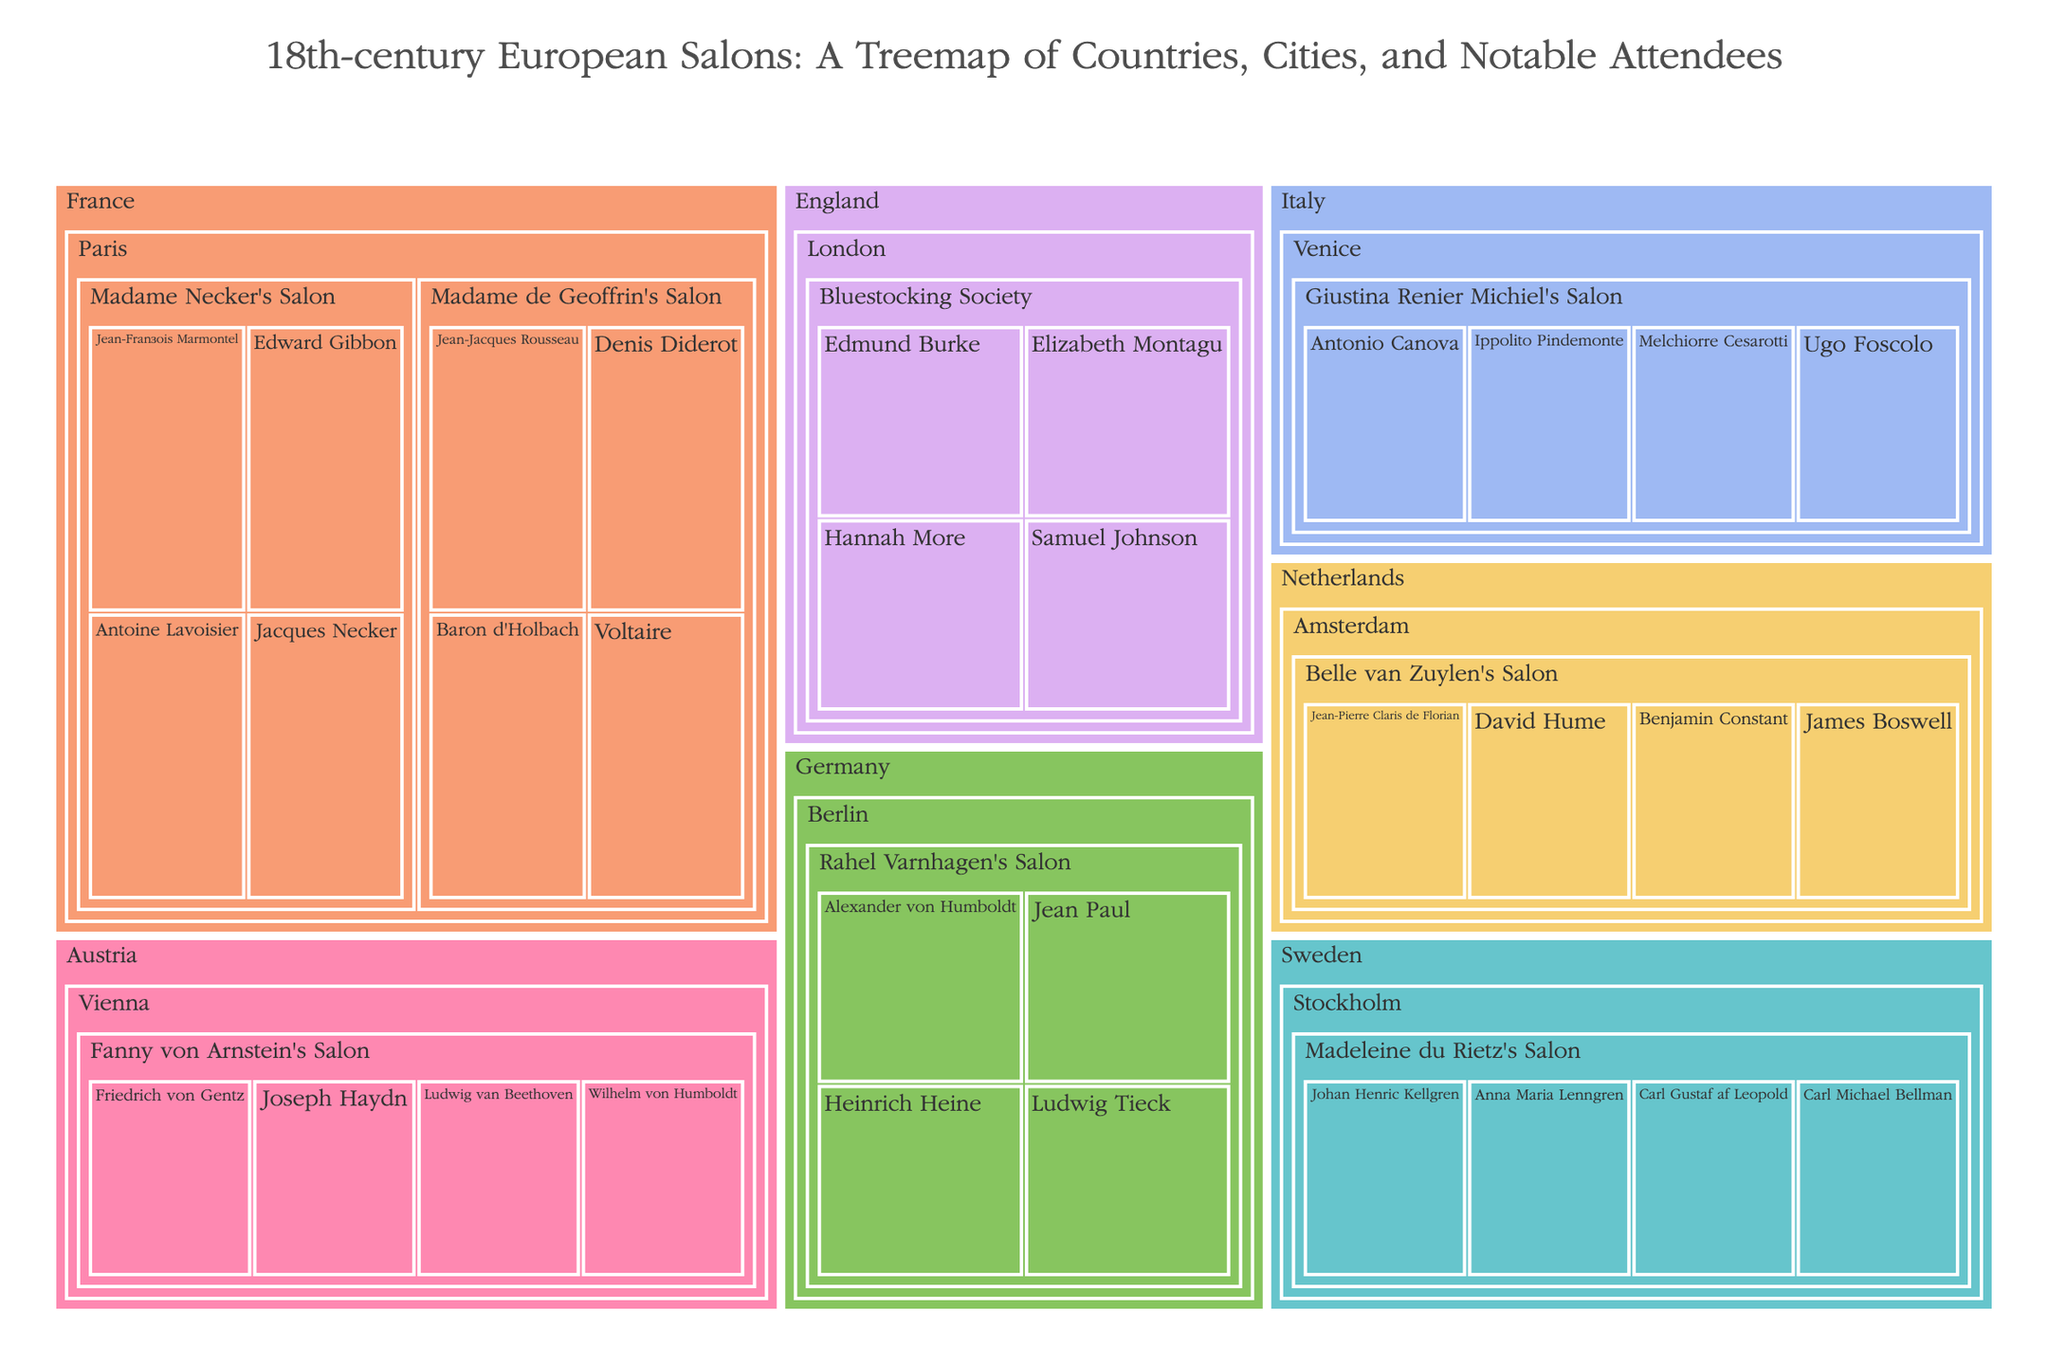What is the title of the treemap? The title of the treemap is located at the top of the figure. Reading it will provide the exact wording.
Answer: 18th-century European Salons: A Treemap of Countries, Cities, and Notable Attendees Which country has the most salons represented? By examining the size of the areas and labels, you can see which country has the most salons displayed.
Answer: France How many notable attendees are listed for Madame de Geoffrin's Salon in Paris, France? Locate the box labeled Madame de Geoffrin's Salon under Paris in France and count the number of attendees listed within.
Answer: 4 Compare the number of notable attendees in Madame Necker's Salon (Paris) to Fanny von Arnstein’s Salon (Vienna). Which has more? Identify the attendees' boxes under each salon and count them. Then compare the two counts.
Answer: Madame Necker's Salon In which city does Elizabeth Montagu's Bluestocking Society hold its salons? Identify the salon named Bluestocking Society, then look upward in the hierarchy to find its city.
Answer: London What's the total number of notable attendees associated with salons in Paris? Identify all salons under Paris. Count their attendees individually, then sum these counts to get the total.
Answer: 8 Which salon has attendees including Benjamin Constant and David Hume? Locate the attendees named Benjamin Constant and David Hume and trace upward in the hierarchy to find the associated salon.
Answer: Belle van Zuylen's Salon Compare the range of cities hosting salons in France to those in Germany. Which country has more cities represented? Count the number of unique cities listed under each country.
Answer: France For the salons listed, which one is associated with the most culturally diverse number of attendees based on their contributions (philosophers, scientists, etc.)? Look at the notable attendees for each salon and consider the variety of their contributions.
Answer: Madame Necker's Salon How many countries are represented in the treemap? Count the number of unique country labels at the highest level in the hierarchy.
Answer: 6 